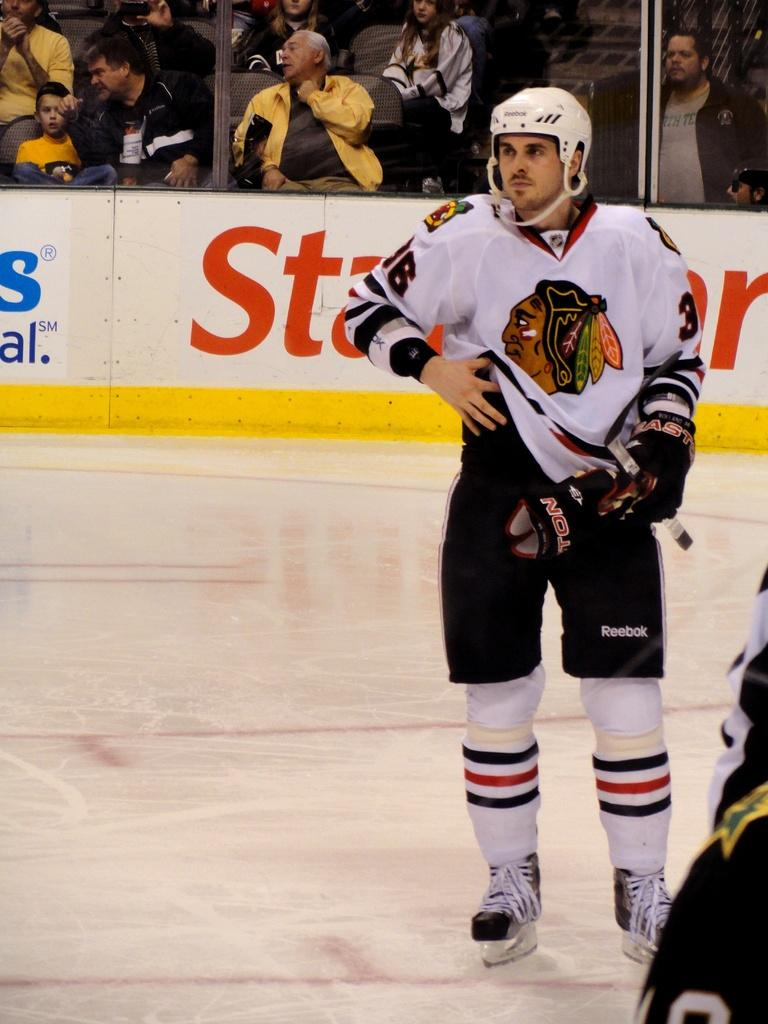How many people are in the image? There are people in the image, but the exact number is not specified. What objects are present in the image that people might sit on? There are chairs in the image. What type of signage can be seen in the image? There are hoardings in the image. What protective gear is the person in the front of the image wearing? A person in the front of the image is wearing a helmet. What type of clothing is the person in the front of the image wearing on their hand? A person in the front of the image is wearing a glove. What type of knee protection is visible on the person in the image? There is no mention of knee protection in the image; the person is wearing a helmet and a glove. What type of cub is sitting on the chair in the image? There is no mention of a cub or any animal in the image; it features people and chairs. 